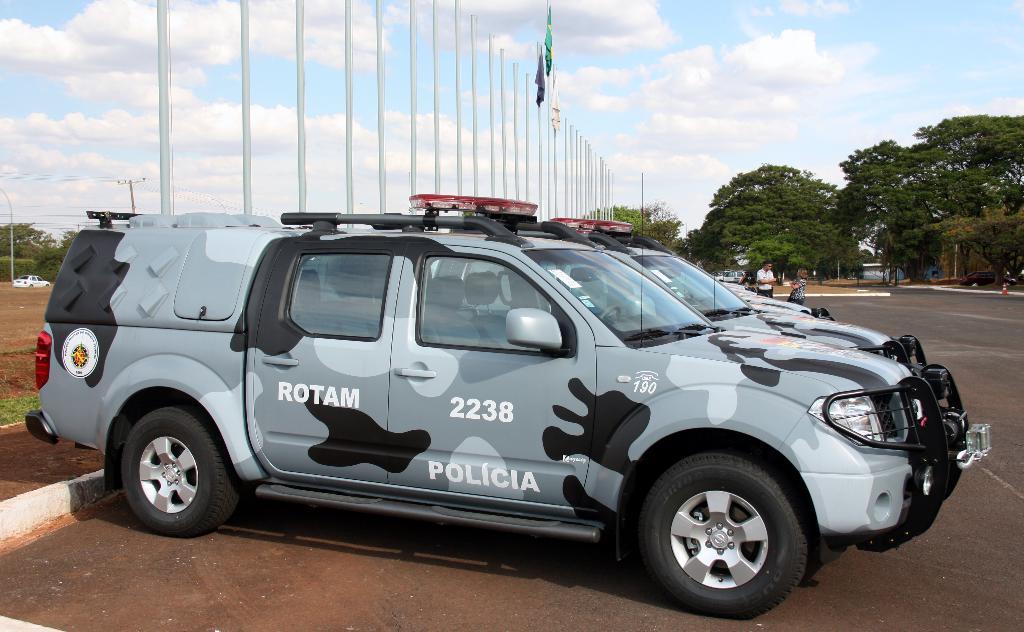Can you describe this image briefly? In this image we can see the police vehicles parked on the road. We can also see the poles and also the flags. Image also consists of trees. We can see a man and a woman in the background. There is sky with the clouds. We can also see an electrical pole with wires. 